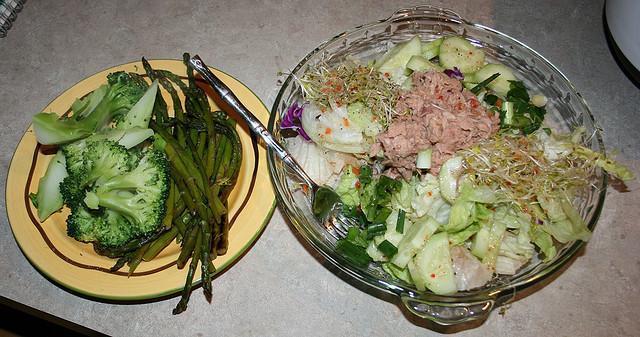How many broccolis can be seen?
Give a very brief answer. 2. How many feet does this woman have on the floor?
Give a very brief answer. 0. 